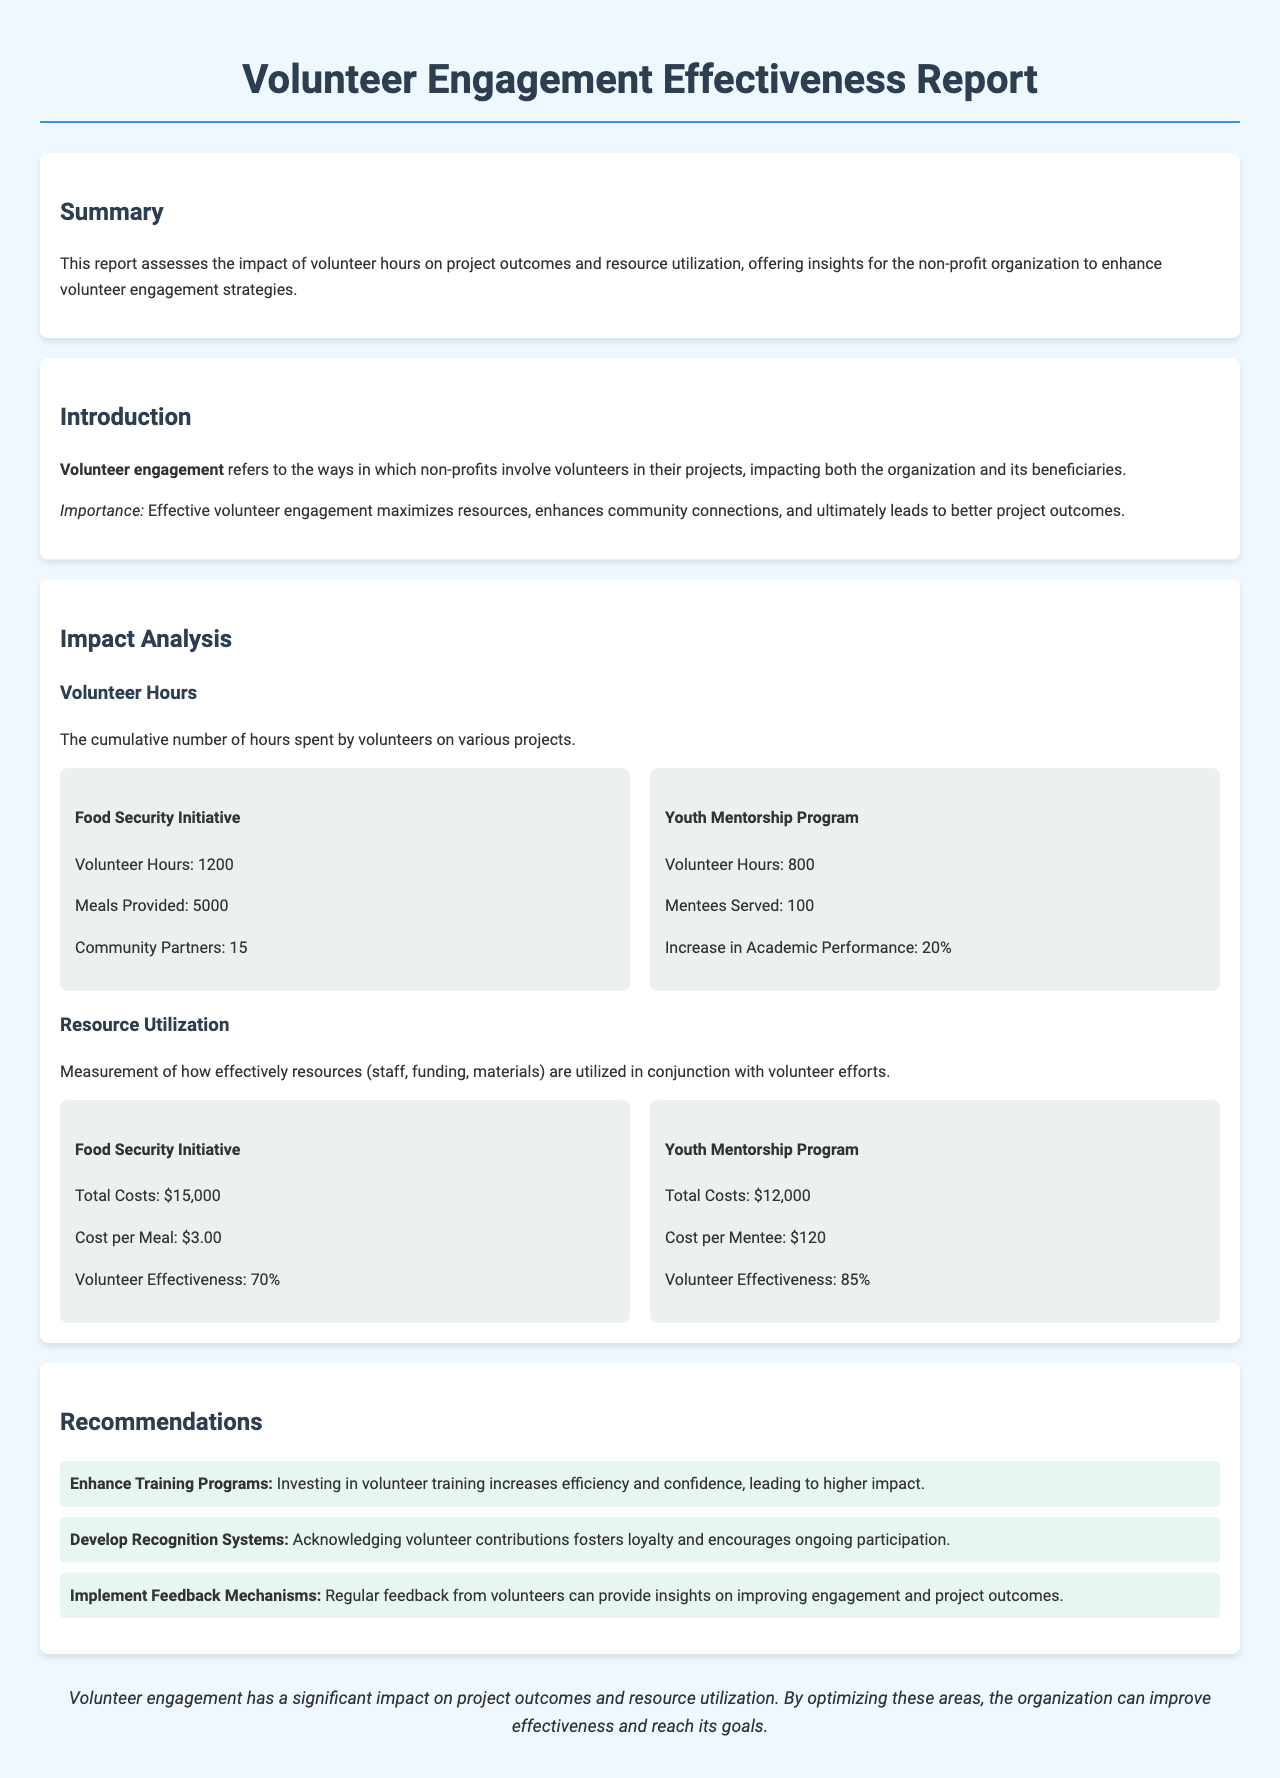What is the total number of volunteer hours for the Food Security Initiative? The document states that the total number of volunteer hours for the Food Security Initiative is 1200.
Answer: 1200 How many meals were provided by the Food Security Initiative? The report indicates that the Food Security Initiative provided 5000 meals.
Answer: 5000 What percentage increase in academic performance is reported in the Youth Mentorship Program? According to the document, there is a 20% increase in academic performance in the Youth Mentorship Program.
Answer: 20% What is the total cost of the Youth Mentorship Program? The report specifies that the total costs for the Youth Mentorship Program amount to $12,000.
Answer: $12,000 What is the volunteer effectiveness percentage for the Food Security Initiative? The document reports that the volunteer effectiveness for the Food Security Initiative is 70%.
Answer: 70% What type of recommendations are provided in the report? The report includes recommendations such as enhancing training programs, developing recognition systems, and implementing feedback mechanisms.
Answer: Enhance Training Programs, Develop Recognition Systems, Implement Feedback Mechanisms What is the cost per meal for the Food Security Initiative? The cost per meal for the Food Security Initiative is stated to be $3.00 in the report.
Answer: $3.00 How many community partners were involved in the Food Security Initiative? The document mentions that there were 15 community partners involved in the Food Security Initiative.
Answer: 15 